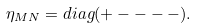<formula> <loc_0><loc_0><loc_500><loc_500>\eta _ { M N } = d i a g ( + - - - - ) .</formula> 